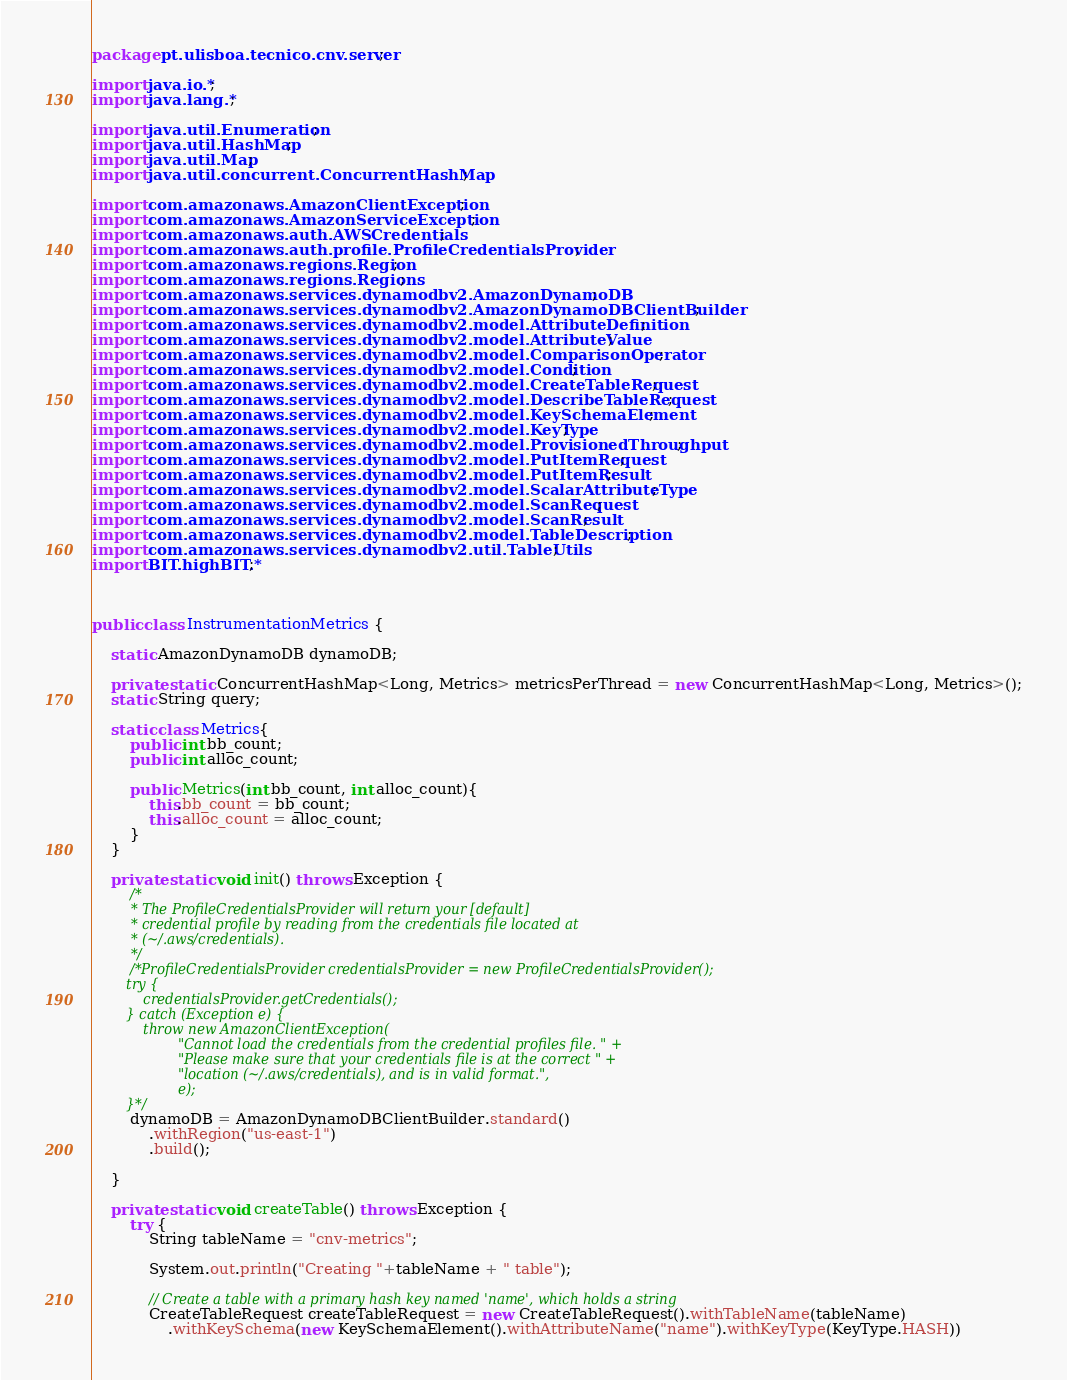Convert code to text. <code><loc_0><loc_0><loc_500><loc_500><_Java_>package pt.ulisboa.tecnico.cnv.server;

import java.io.*;
import java.lang.*;

import java.util.Enumeration;
import java.util.HashMap;
import java.util.Map;
import java.util.concurrent.ConcurrentHashMap;

import com.amazonaws.AmazonClientException;
import com.amazonaws.AmazonServiceException;
import com.amazonaws.auth.AWSCredentials;
import com.amazonaws.auth.profile.ProfileCredentialsProvider;
import com.amazonaws.regions.Region;
import com.amazonaws.regions.Regions;
import com.amazonaws.services.dynamodbv2.AmazonDynamoDB;
import com.amazonaws.services.dynamodbv2.AmazonDynamoDBClientBuilder;
import com.amazonaws.services.dynamodbv2.model.AttributeDefinition;
import com.amazonaws.services.dynamodbv2.model.AttributeValue;
import com.amazonaws.services.dynamodbv2.model.ComparisonOperator;
import com.amazonaws.services.dynamodbv2.model.Condition;
import com.amazonaws.services.dynamodbv2.model.CreateTableRequest;
import com.amazonaws.services.dynamodbv2.model.DescribeTableRequest;
import com.amazonaws.services.dynamodbv2.model.KeySchemaElement;
import com.amazonaws.services.dynamodbv2.model.KeyType;
import com.amazonaws.services.dynamodbv2.model.ProvisionedThroughput;
import com.amazonaws.services.dynamodbv2.model.PutItemRequest;
import com.amazonaws.services.dynamodbv2.model.PutItemResult;
import com.amazonaws.services.dynamodbv2.model.ScalarAttributeType;
import com.amazonaws.services.dynamodbv2.model.ScanRequest;
import com.amazonaws.services.dynamodbv2.model.ScanResult;
import com.amazonaws.services.dynamodbv2.model.TableDescription;
import com.amazonaws.services.dynamodbv2.util.TableUtils;
import BIT.highBIT.*;



public class InstrumentationMetrics {

    static AmazonDynamoDB dynamoDB;

    private static ConcurrentHashMap<Long, Metrics> metricsPerThread = new ConcurrentHashMap<Long, Metrics>();
    static String query;

    static class Metrics{
        public int bb_count;
        public int alloc_count;

        public Metrics(int bb_count, int alloc_count){
            this.bb_count = bb_count;
            this.alloc_count = alloc_count;
        }
    }

    private static void init() throws Exception {
        /*
         * The ProfileCredentialsProvider will return your [default]
         * credential profile by reading from the credentials file located at
         * (~/.aws/credentials).
         */
        /*ProfileCredentialsProvider credentialsProvider = new ProfileCredentialsProvider();
        try {
            credentialsProvider.getCredentials();
        } catch (Exception e) {
            throw new AmazonClientException(
                    "Cannot load the credentials from the credential profiles file. " +
                    "Please make sure that your credentials file is at the correct " +
                    "location (~/.aws/credentials), and is in valid format.",
                    e);
        }*/
        dynamoDB = AmazonDynamoDBClientBuilder.standard()
            .withRegion("us-east-1")
            .build();

    }

    private static void createTable() throws Exception {
        try {
            String tableName = "cnv-metrics";

            System.out.println("Creating "+tableName + " table");

            // Create a table with a primary hash key named 'name', which holds a string
            CreateTableRequest createTableRequest = new CreateTableRequest().withTableName(tableName)
                .withKeySchema(new KeySchemaElement().withAttributeName("name").withKeyType(KeyType.HASH))</code> 